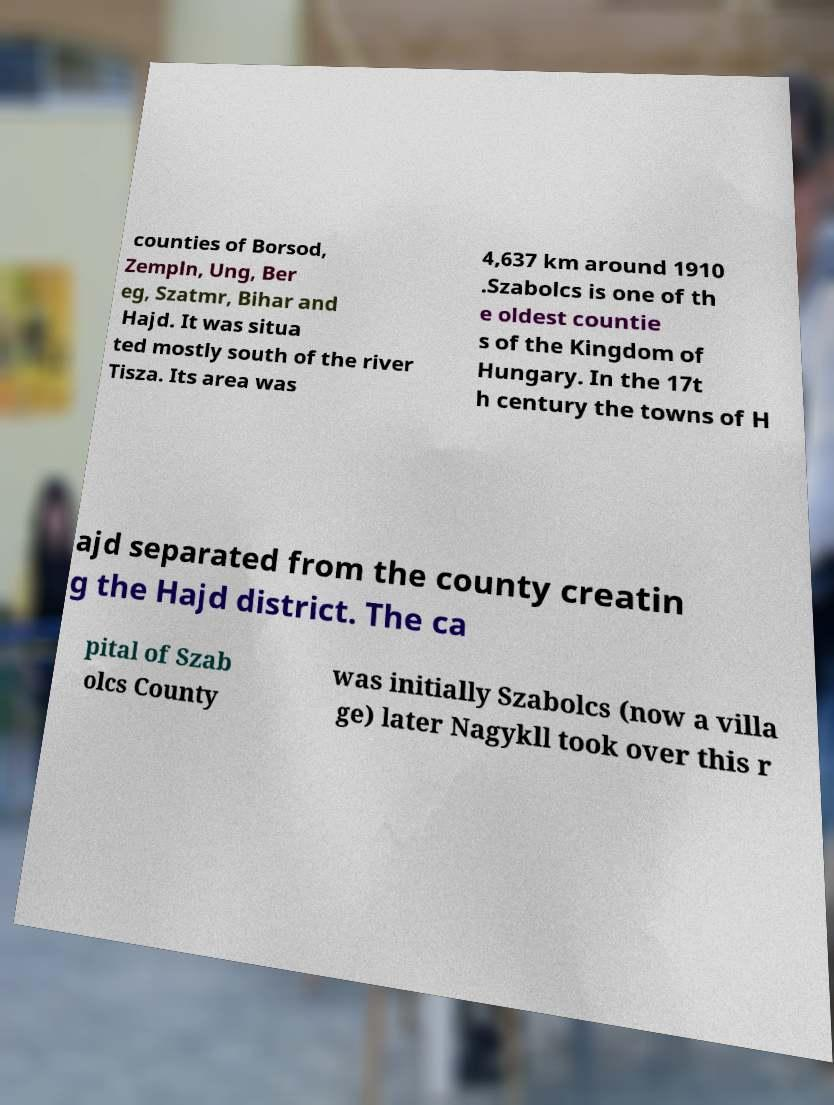Please read and relay the text visible in this image. What does it say? counties of Borsod, Zempln, Ung, Ber eg, Szatmr, Bihar and Hajd. It was situa ted mostly south of the river Tisza. Its area was 4,637 km around 1910 .Szabolcs is one of th e oldest countie s of the Kingdom of Hungary. In the 17t h century the towns of H ajd separated from the county creatin g the Hajd district. The ca pital of Szab olcs County was initially Szabolcs (now a villa ge) later Nagykll took over this r 